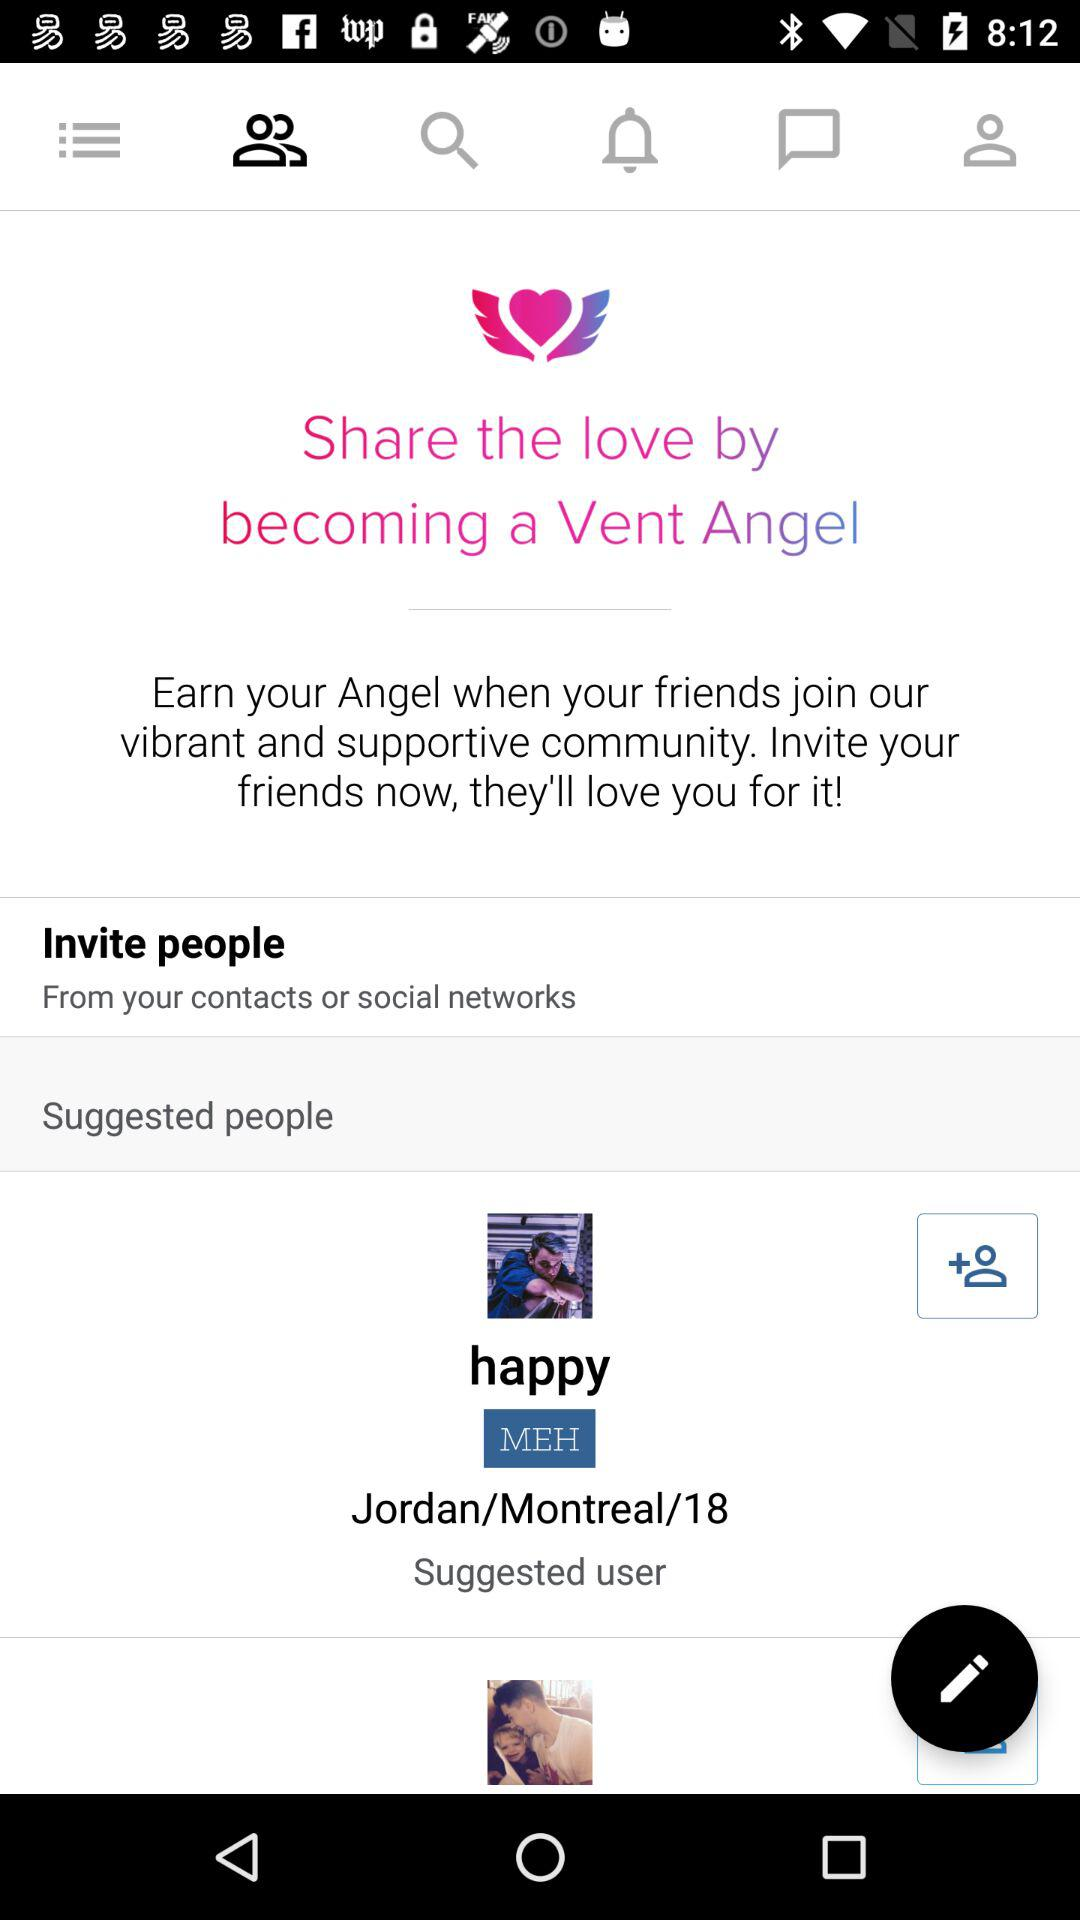How many suggested users are there on the screen?
Answer the question using a single word or phrase. 2 